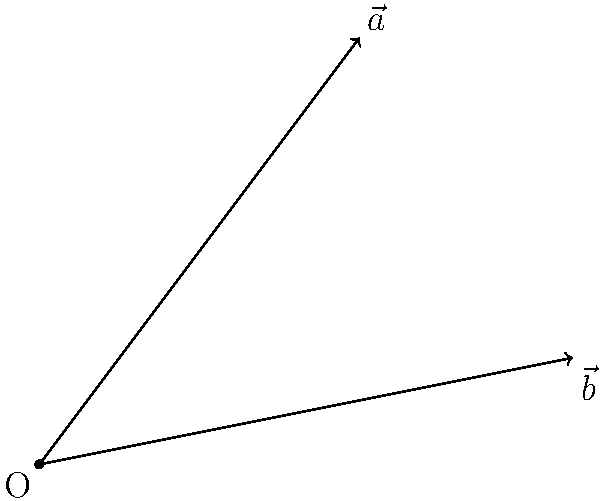In the 2D plane shown above, vectors $\vec{a}$ and $\vec{b}$ are represented. Calculate the angle between these two vectors. Express your answer in radians, rounded to two decimal places. To find the angle between two vectors, we can use the dot product formula:

$$\cos \theta = \frac{\vec{a} \cdot \vec{b}}{|\vec{a}| |\vec{b}|}$$

Step 1: Determine the components of each vector
$\vec{a} = (3, 4)$
$\vec{b} = (5, 1)$

Step 2: Calculate the dot product $\vec{a} \cdot \vec{b}$
$\vec{a} \cdot \vec{b} = (3 \times 5) + (4 \times 1) = 15 + 4 = 19$

Step 3: Calculate the magnitudes of the vectors
$|\vec{a}| = \sqrt{3^2 + 4^2} = \sqrt{25} = 5$
$|\vec{b}| = \sqrt{5^2 + 1^2} = \sqrt{26}$

Step 4: Apply the dot product formula
$$\cos \theta = \frac{19}{5 \sqrt{26}}$$

Step 5: Take the inverse cosine (arccos) of both sides
$$\theta = \arccos(\frac{19}{5 \sqrt{26}}) \approx 0.5748 \text{ radians}$$

Step 6: Round to two decimal places
$\theta \approx 0.57 \text{ radians}$
Answer: 0.57 radians 